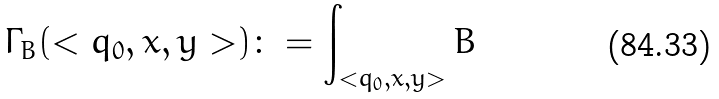<formula> <loc_0><loc_0><loc_500><loc_500>\Gamma _ { B } ( < q _ { 0 } , x , y > ) \colon = \int _ { < q _ { 0 } , x , y > } B</formula> 